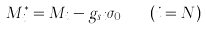Convert formula to latex. <formula><loc_0><loc_0><loc_500><loc_500>M _ { i } ^ { \ast } = M _ { i } - g _ { s i } \sigma _ { 0 } \quad ( i = N )</formula> 